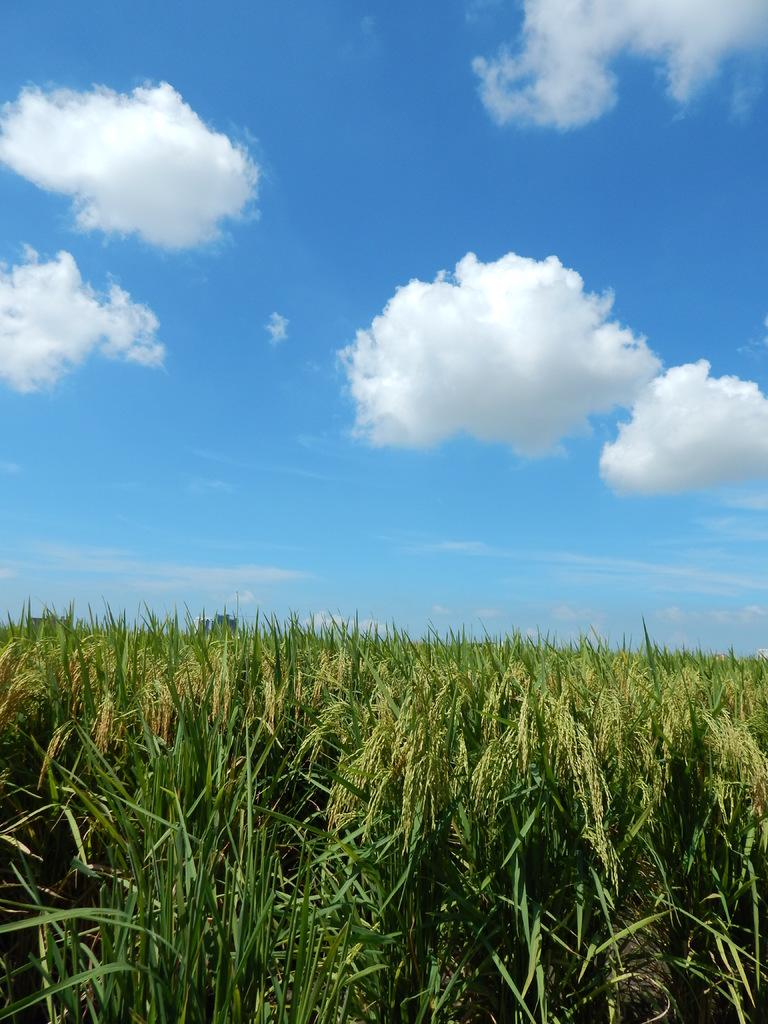What type of vegetation is at the bottom of the image? There is grass at the bottom of the image. What is visible at the top of the image? The sky is visible at the top of the image. What can be seen in the sky? Clouds are present in the sky. How many matches are visible in the image? There are no matches present in the image. What type of cord is hanging from the clouds in the image? There is no cord hanging from the clouds in the image. 